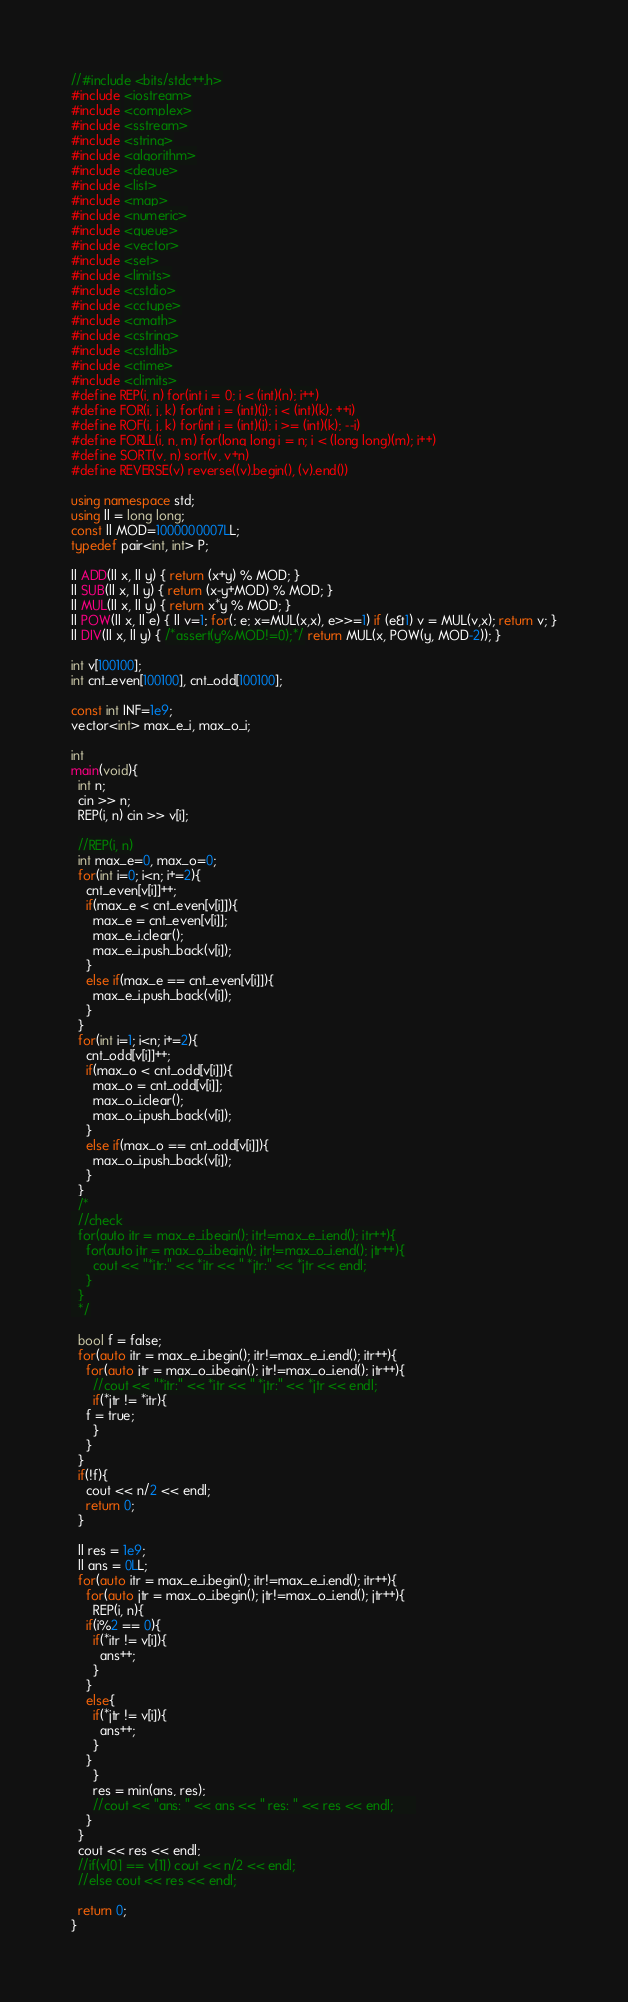Convert code to text. <code><loc_0><loc_0><loc_500><loc_500><_C++_>//#include <bits/stdc++.h>
#include <iostream>
#include <complex>
#include <sstream>
#include <string>
#include <algorithm>
#include <deque>
#include <list>
#include <map>
#include <numeric>
#include <queue>
#include <vector>
#include <set>
#include <limits>
#include <cstdio>
#include <cctype>
#include <cmath>
#include <cstring>
#include <cstdlib>
#include <ctime>
#include <climits>
#define REP(i, n) for(int i = 0; i < (int)(n); i++)
#define FOR(i, j, k) for(int i = (int)(j); i < (int)(k); ++i)
#define ROF(i, j, k) for(int i = (int)(j); i >= (int)(k); --i)
#define FORLL(i, n, m) for(long long i = n; i < (long long)(m); i++)
#define SORT(v, n) sort(v, v+n)
#define REVERSE(v) reverse((v).begin(), (v).end())

using namespace std;
using ll = long long;
const ll MOD=1000000007LL;
typedef pair<int, int> P;

ll ADD(ll x, ll y) { return (x+y) % MOD; }
ll SUB(ll x, ll y) { return (x-y+MOD) % MOD; }
ll MUL(ll x, ll y) { return x*y % MOD; }
ll POW(ll x, ll e) { ll v=1; for(; e; x=MUL(x,x), e>>=1) if (e&1) v = MUL(v,x); return v; }
ll DIV(ll x, ll y) { /*assert(y%MOD!=0);*/ return MUL(x, POW(y, MOD-2)); }

int v[100100];
int cnt_even[100100], cnt_odd[100100];

const int INF=1e9;
vector<int> max_e_i, max_o_i;

int
main(void){  
  int n;
  cin >> n;
  REP(i, n) cin >> v[i];
  
  //REP(i, n)
  int max_e=0, max_o=0;
  for(int i=0; i<n; i+=2){    
    cnt_even[v[i]]++;
    if(max_e < cnt_even[v[i]]){
      max_e = cnt_even[v[i]];
      max_e_i.clear();
      max_e_i.push_back(v[i]);
    }
    else if(max_e == cnt_even[v[i]]){
      max_e_i.push_back(v[i]);      
    }
  }
  for(int i=1; i<n; i+=2){
    cnt_odd[v[i]]++;
    if(max_o < cnt_odd[v[i]]){
      max_o = cnt_odd[v[i]];
      max_o_i.clear();
      max_o_i.push_back(v[i]);      
    }
    else if(max_o == cnt_odd[v[i]]){      
      max_o_i.push_back(v[i]);
    }
  }
  /*
  //check
  for(auto itr = max_e_i.begin(); itr!=max_e_i.end(); itr++){
    for(auto jtr = max_o_i.begin(); jtr!=max_o_i.end(); jtr++){
      cout << "*itr:" << *itr << " *jtr:" << *jtr << endl;
    }
  }
  */
  
  bool f = false;
  for(auto itr = max_e_i.begin(); itr!=max_e_i.end(); itr++){
    for(auto jtr = max_o_i.begin(); jtr!=max_o_i.end(); jtr++){
      //cout << "*itr:" << *itr << " *jtr:" << *jtr << endl;
      if(*jtr != *itr){
	f = true;
      }
    }
  }
  if(!f){
    cout << n/2 << endl;
    return 0;
  }
  
  ll res = 1e9;
  ll ans = 0LL;
  for(auto itr = max_e_i.begin(); itr!=max_e_i.end(); itr++){
    for(auto jtr = max_o_i.begin(); jtr!=max_o_i.end(); jtr++){  
      REP(i, n){
	if(i%2 == 0){      
	  if(*itr != v[i]){
	    ans++;
	  }      
	}
	else{
	  if(*jtr != v[i]){
	    ans++;
	  }
	}
      }
      res = min(ans, res);
      //cout << "ans: " << ans << " res: " << res << endl;      
    }
  }
  cout << res << endl;
  //if(v[0] == v[1]) cout << n/2 << endl;
  //else cout << res << endl;
  
  return 0;
}
</code> 